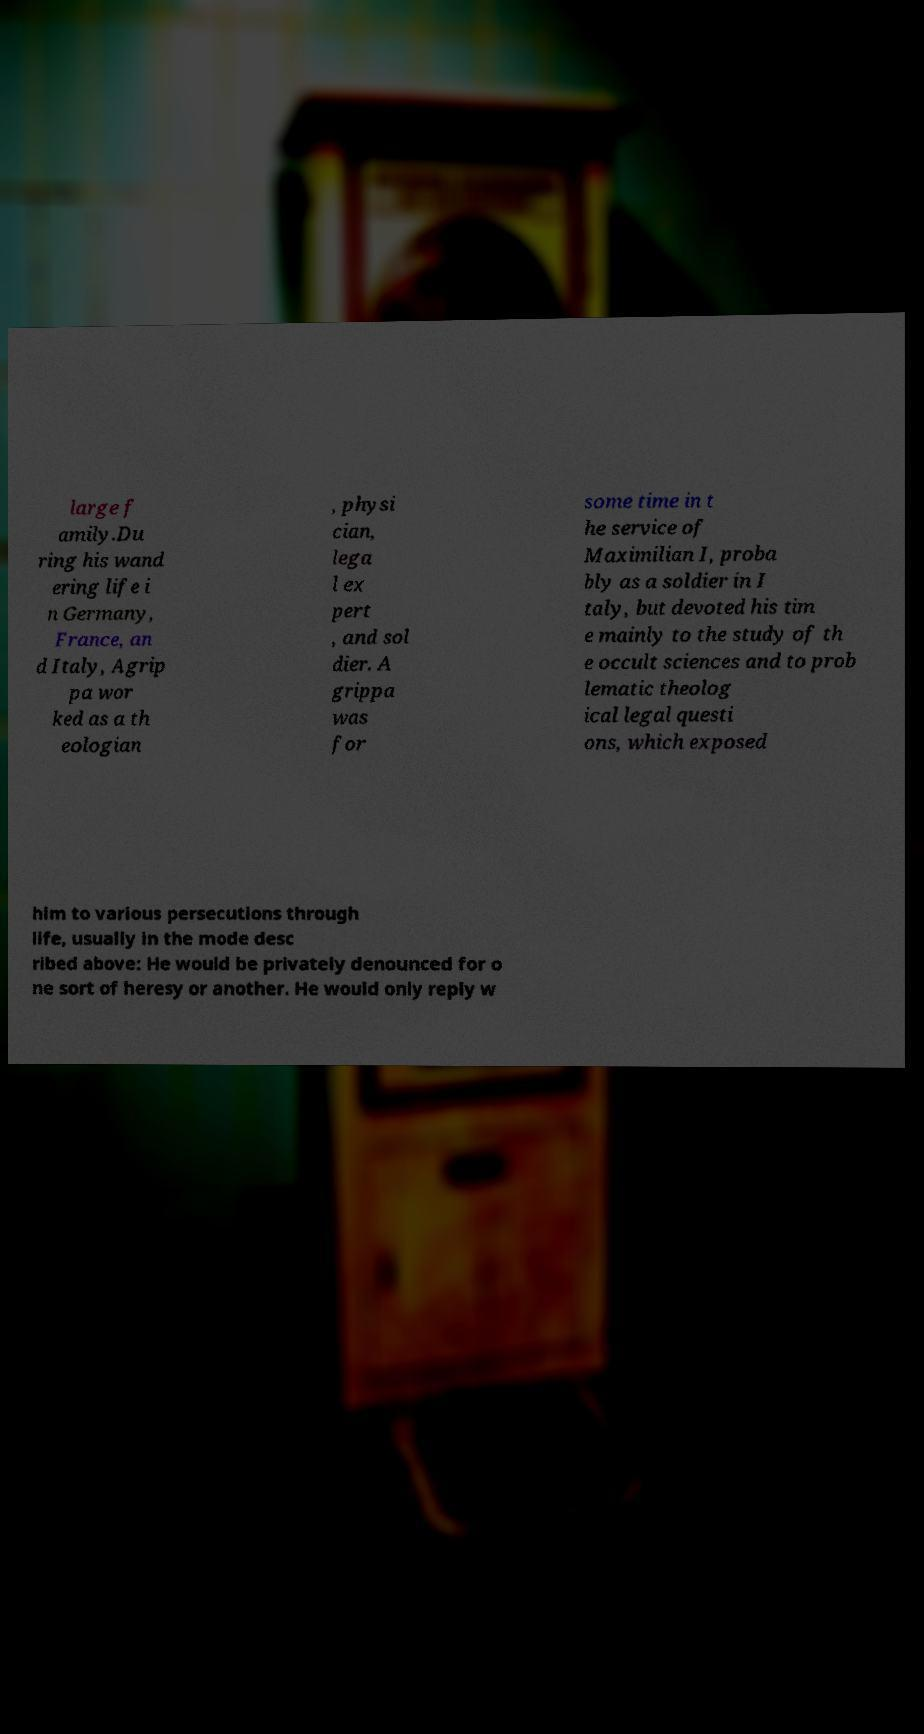Could you assist in decoding the text presented in this image and type it out clearly? large f amily.Du ring his wand ering life i n Germany, France, an d Italy, Agrip pa wor ked as a th eologian , physi cian, lega l ex pert , and sol dier. A grippa was for some time in t he service of Maximilian I, proba bly as a soldier in I taly, but devoted his tim e mainly to the study of th e occult sciences and to prob lematic theolog ical legal questi ons, which exposed him to various persecutions through life, usually in the mode desc ribed above: He would be privately denounced for o ne sort of heresy or another. He would only reply w 